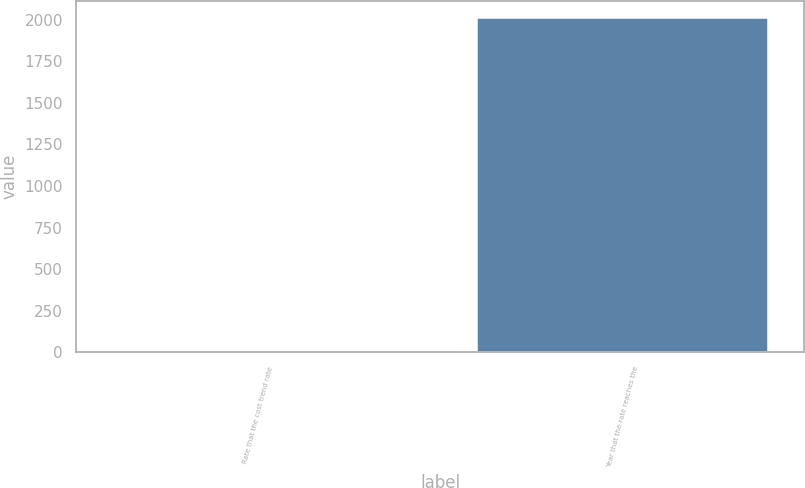Convert chart to OTSL. <chart><loc_0><loc_0><loc_500><loc_500><bar_chart><fcel>Rate that the cost trend rate<fcel>Year that the rate reaches the<nl><fcel>5<fcel>2010<nl></chart> 